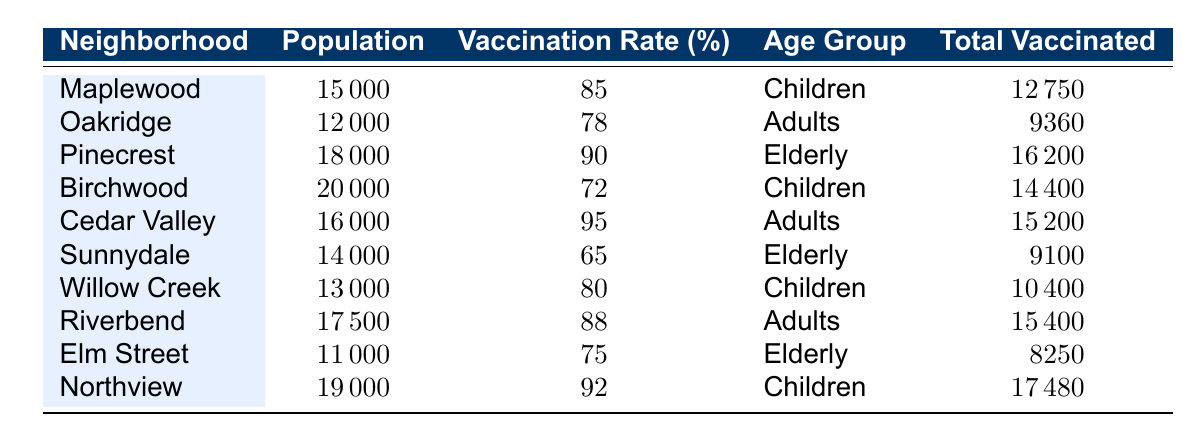What is the vaccination rate for the neighborhood Cedar Valley? The table indicates that Cedar Valley has a vaccination rate of 95%.
Answer: 95% Which neighborhood has the highest total vaccinated count? By looking at the Total Vaccinated column, Pinecrest has 16200, which is the highest.
Answer: Pinecrest What is the average vaccination rate for neighborhoods with children as their age group? The neighborhoods with children are Maplewood (85%), Birchwood (72%), Willow Creek (80%), and Northview (92%). The average is (85 + 72 + 80 + 92) / 4 = 332 / 4 = 83.
Answer: 83 Is the vaccination rate in Sunnydale above 70%? The table shows that Sunnydale has a vaccination rate of 65%, which is below 70%.
Answer: No How many more people were vaccinated in Pinecrest compared to Sunnydale? Pinecrest had 16200 vaccinated, while Sunnydale had 9100 vaccinated. The difference is 16200 - 9100 = 7100.
Answer: 7100 What is the total population of all neighborhoods combined? The populations of the neighborhoods are 15000, 12000, 18000, 20000, 16000, 14000, 13000, 17500, 11000, and 19000. Adding them gives a total of 15000 + 12000 + 18000 + 20000 + 16000 + 14000 + 13000 + 17500 + 11000 + 19000 = 150500.
Answer: 150500 Which age group has the lowest vaccination rate, and what is that rate? Looking at the age groups and their vaccination rates, Sunnydale's elderly group has the lowest rate at 65%.
Answer: Elderly, 65% Are there any neighborhoods where the vaccination rate is below 75%? Yes, looking at the vaccination rates, Birchwood (72%) and Sunnydale (65%) have rates below 75%.
Answer: Yes 